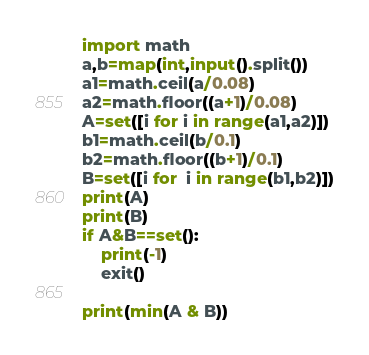Convert code to text. <code><loc_0><loc_0><loc_500><loc_500><_Python_>import math
a,b=map(int,input().split())
a1=math.ceil(a/0.08)
a2=math.floor((a+1)/0.08)
A=set([i for i in range(a1,a2)])
b1=math.ceil(b/0.1)
b2=math.floor((b+1)/0.1)
B=set([i for  i in range(b1,b2)])
print(A)
print(B)
if A&B==set(): 
    print(-1)
    exit()

print(min(A & B))</code> 